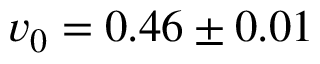<formula> <loc_0><loc_0><loc_500><loc_500>v _ { 0 } = 0 . 4 6 \pm 0 . 0 1</formula> 